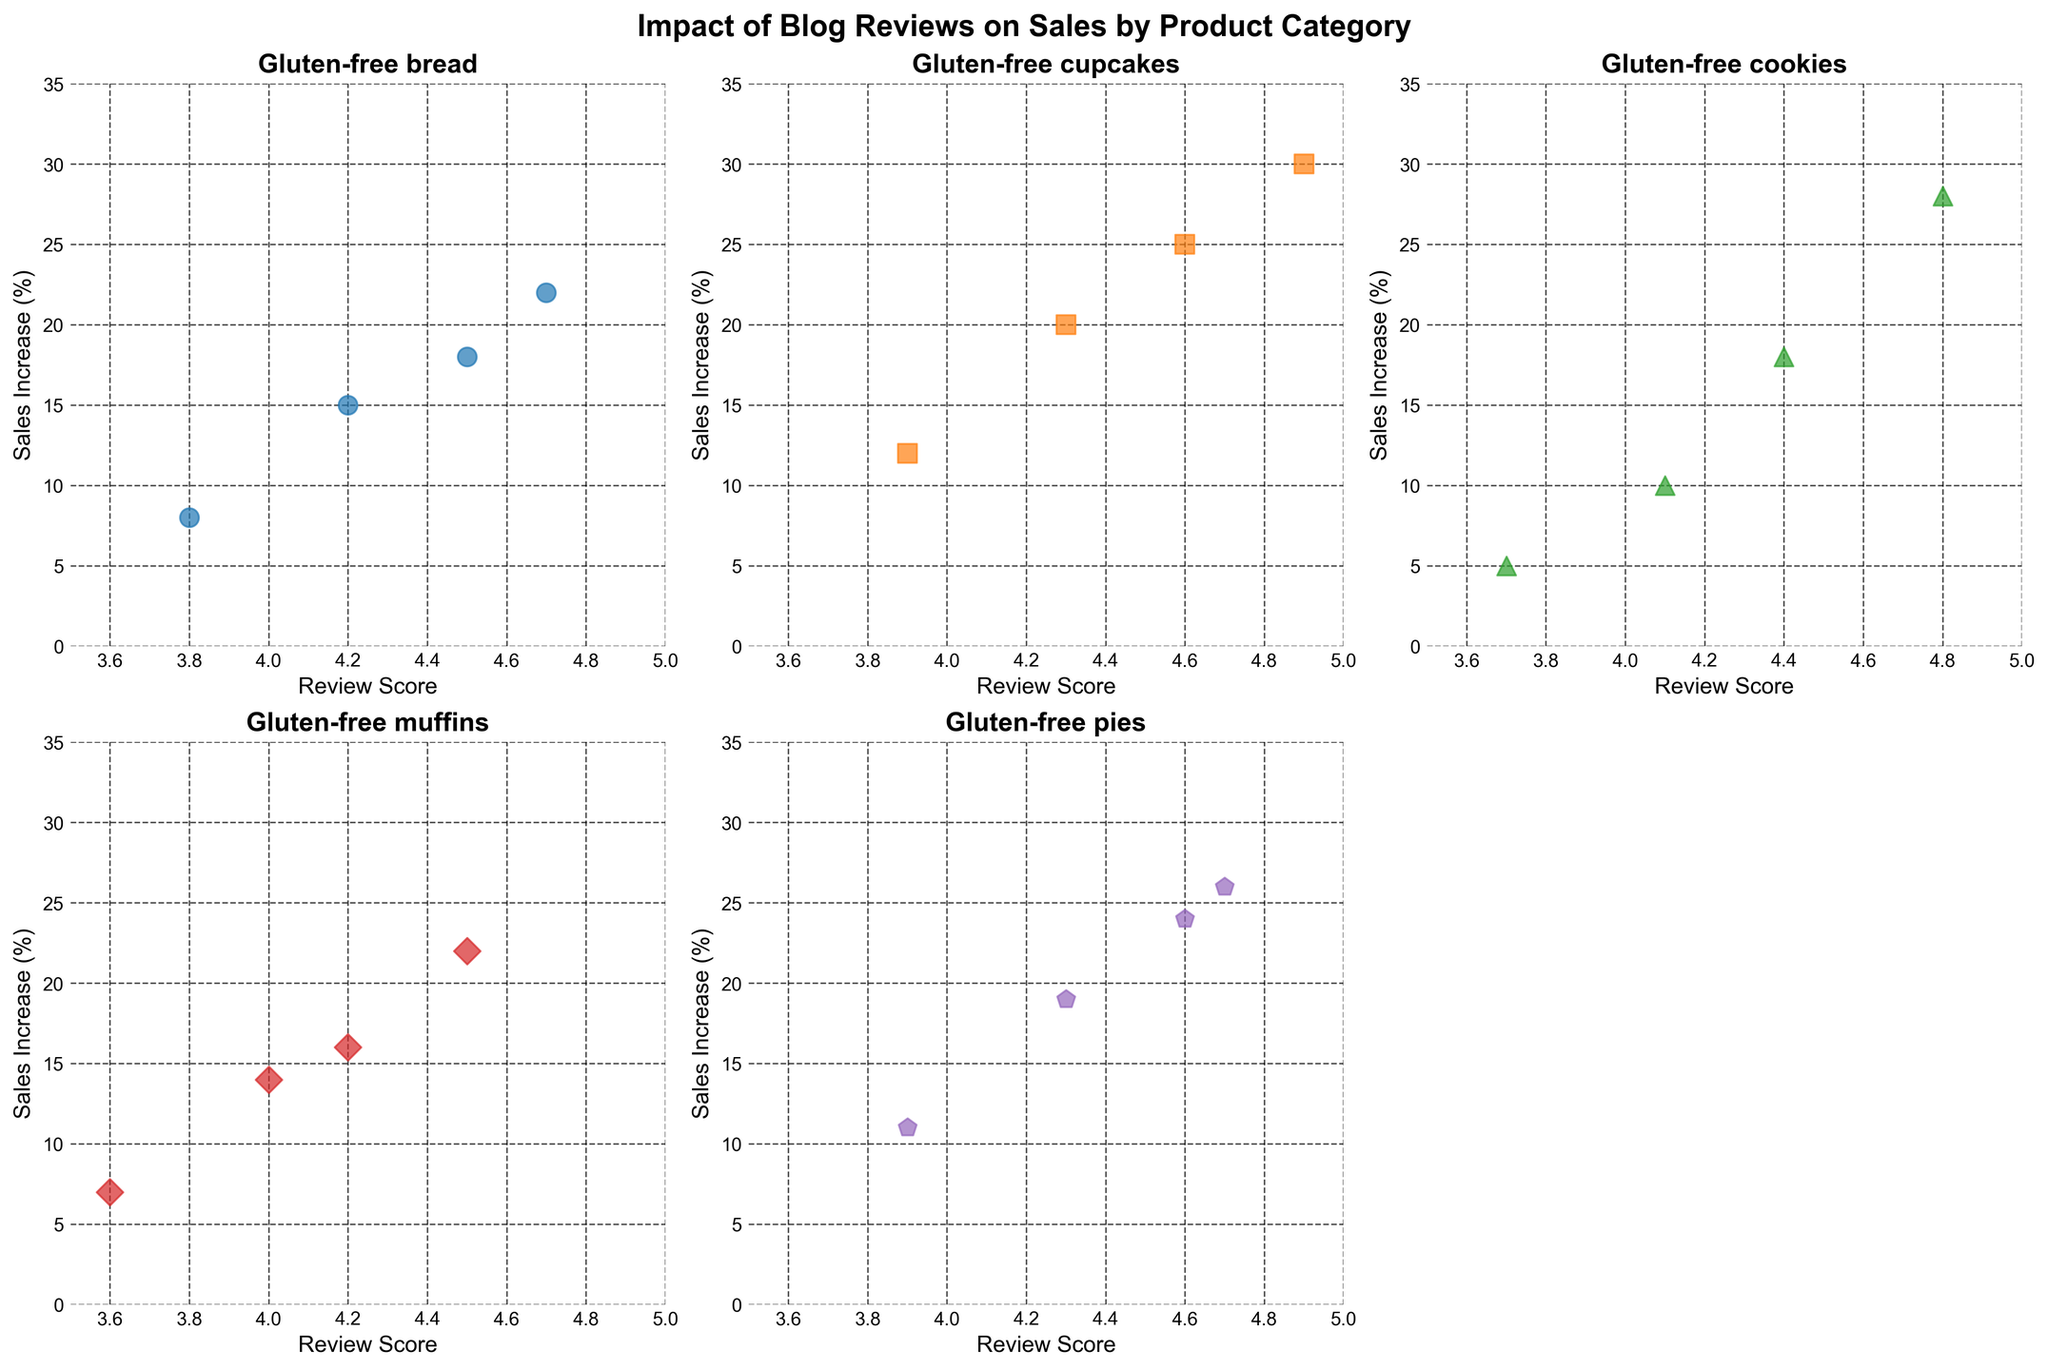Which product category shows the highest sales increase for a given review score? By examining the scatter plots, you can compare sales increases across different product categories. Look for the category with consistently higher sales for given review scores.
Answer: Gluten-free cupcakes What's the overall trend between review scores and sales increase for gluten-free bread? To determine the trend, observe how the points are distributed within the scatter plot for gluten-free bread. A positive trend indicates higher sales increase with higher review scores.
Answer: Positive trend Does any product category show a more significant scatter or variability in sales increase? Assess the spread of the data points within each category's scatter plot. Categories with points spread out more widely display greater variability in sales increase.
Answer: Gluten-free cookies How do the sales increases of 4.5 review scores compare between gluten-free muffins and gluten-free bread? Locate the points where the review score is 4.5 in each scatter plot for muffins and bread. Compare the corresponding sales increase values.
Answer: Muffins have a higher sales increase (22 vs. 18) Which product category has the least number of data points represented? Count the number of data points in each scatter plot. The scatter plot with the fewest points represents the category with the least data.
Answer: Gluten-free pies Is there a product category where a higher review score (around 4.8) does not significantly impact sales increase? Check the scatter plots to see if the sales increase for review scores around 4.8 is substantially different than other scores within any category.
Answer: Gluten-free cookies What is the sales increase range for gluten-free cupcakes? Identify the minimum and maximum sales increase values in the scatter plot for gluten-free cupcakes to determine the range.
Answer: 12 to 30 Which product category shows the steepest increase in sales with review score increments? Compare the slopes of the trends in the scatter plots across categories. Categories with steeper slopes show more significant increases in sales with each increment in review score.
Answer: Gluten-free cupcakes For gluten-free pies, what is the average sales increase for review scores of 4.3 and above? Identify the points with review scores of 4.3 and above in the gluten-free pies scatter plot and calculate the average of their sales increases. Add the sales increases and divide by the number of points.
Answer: (19 + 24 + 26) / 3 = 23 Are there any categories where sales increase seems unaffected by the range of review scores presented? Observe the distribution of points in each scatter plot. Categories where points do not show a strong pattern or clustering indicating increased sales with higher review scores suggest limited impact.
Answer: Gluten-free cookies 